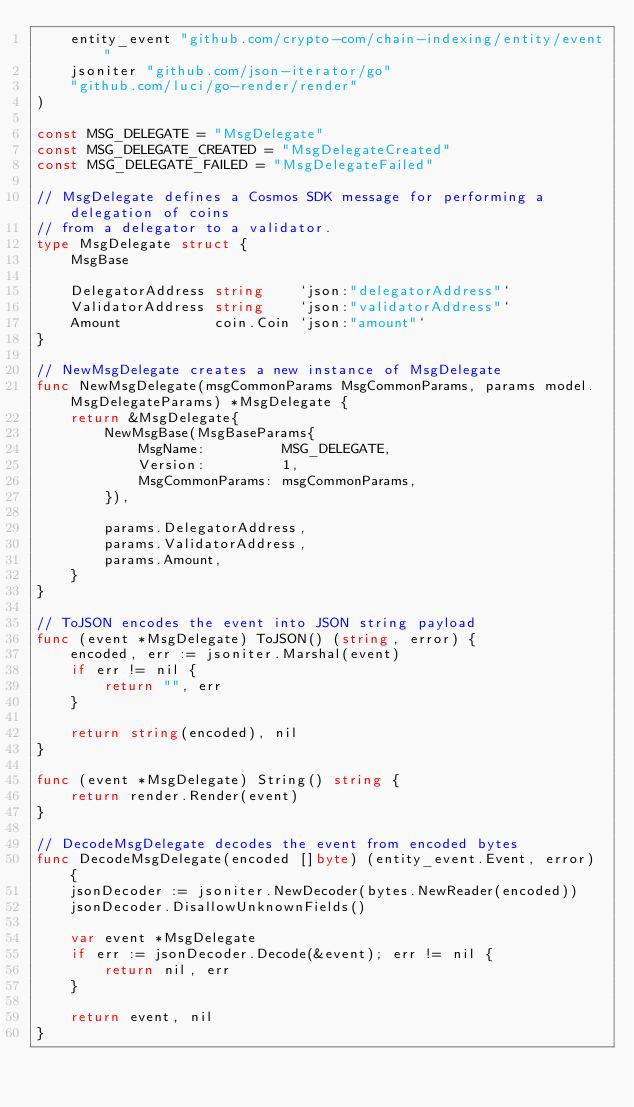Convert code to text. <code><loc_0><loc_0><loc_500><loc_500><_Go_>	entity_event "github.com/crypto-com/chain-indexing/entity/event"
	jsoniter "github.com/json-iterator/go"
	"github.com/luci/go-render/render"
)

const MSG_DELEGATE = "MsgDelegate"
const MSG_DELEGATE_CREATED = "MsgDelegateCreated"
const MSG_DELEGATE_FAILED = "MsgDelegateFailed"

// MsgDelegate defines a Cosmos SDK message for performing a delegation of coins
// from a delegator to a validator.
type MsgDelegate struct {
	MsgBase

	DelegatorAddress string    `json:"delegatorAddress"`
	ValidatorAddress string    `json:"validatorAddress"`
	Amount           coin.Coin `json:"amount"`
}

// NewMsgDelegate creates a new instance of MsgDelegate
func NewMsgDelegate(msgCommonParams MsgCommonParams, params model.MsgDelegateParams) *MsgDelegate {
	return &MsgDelegate{
		NewMsgBase(MsgBaseParams{
			MsgName:         MSG_DELEGATE,
			Version:         1,
			MsgCommonParams: msgCommonParams,
		}),

		params.DelegatorAddress,
		params.ValidatorAddress,
		params.Amount,
	}
}

// ToJSON encodes the event into JSON string payload
func (event *MsgDelegate) ToJSON() (string, error) {
	encoded, err := jsoniter.Marshal(event)
	if err != nil {
		return "", err
	}

	return string(encoded), nil
}

func (event *MsgDelegate) String() string {
	return render.Render(event)
}

// DecodeMsgDelegate decodes the event from encoded bytes
func DecodeMsgDelegate(encoded []byte) (entity_event.Event, error) {
	jsonDecoder := jsoniter.NewDecoder(bytes.NewReader(encoded))
	jsonDecoder.DisallowUnknownFields()

	var event *MsgDelegate
	if err := jsonDecoder.Decode(&event); err != nil {
		return nil, err
	}

	return event, nil
}
</code> 